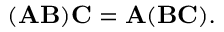<formula> <loc_0><loc_0><loc_500><loc_500>( A B ) C = A ( B C ) .</formula> 